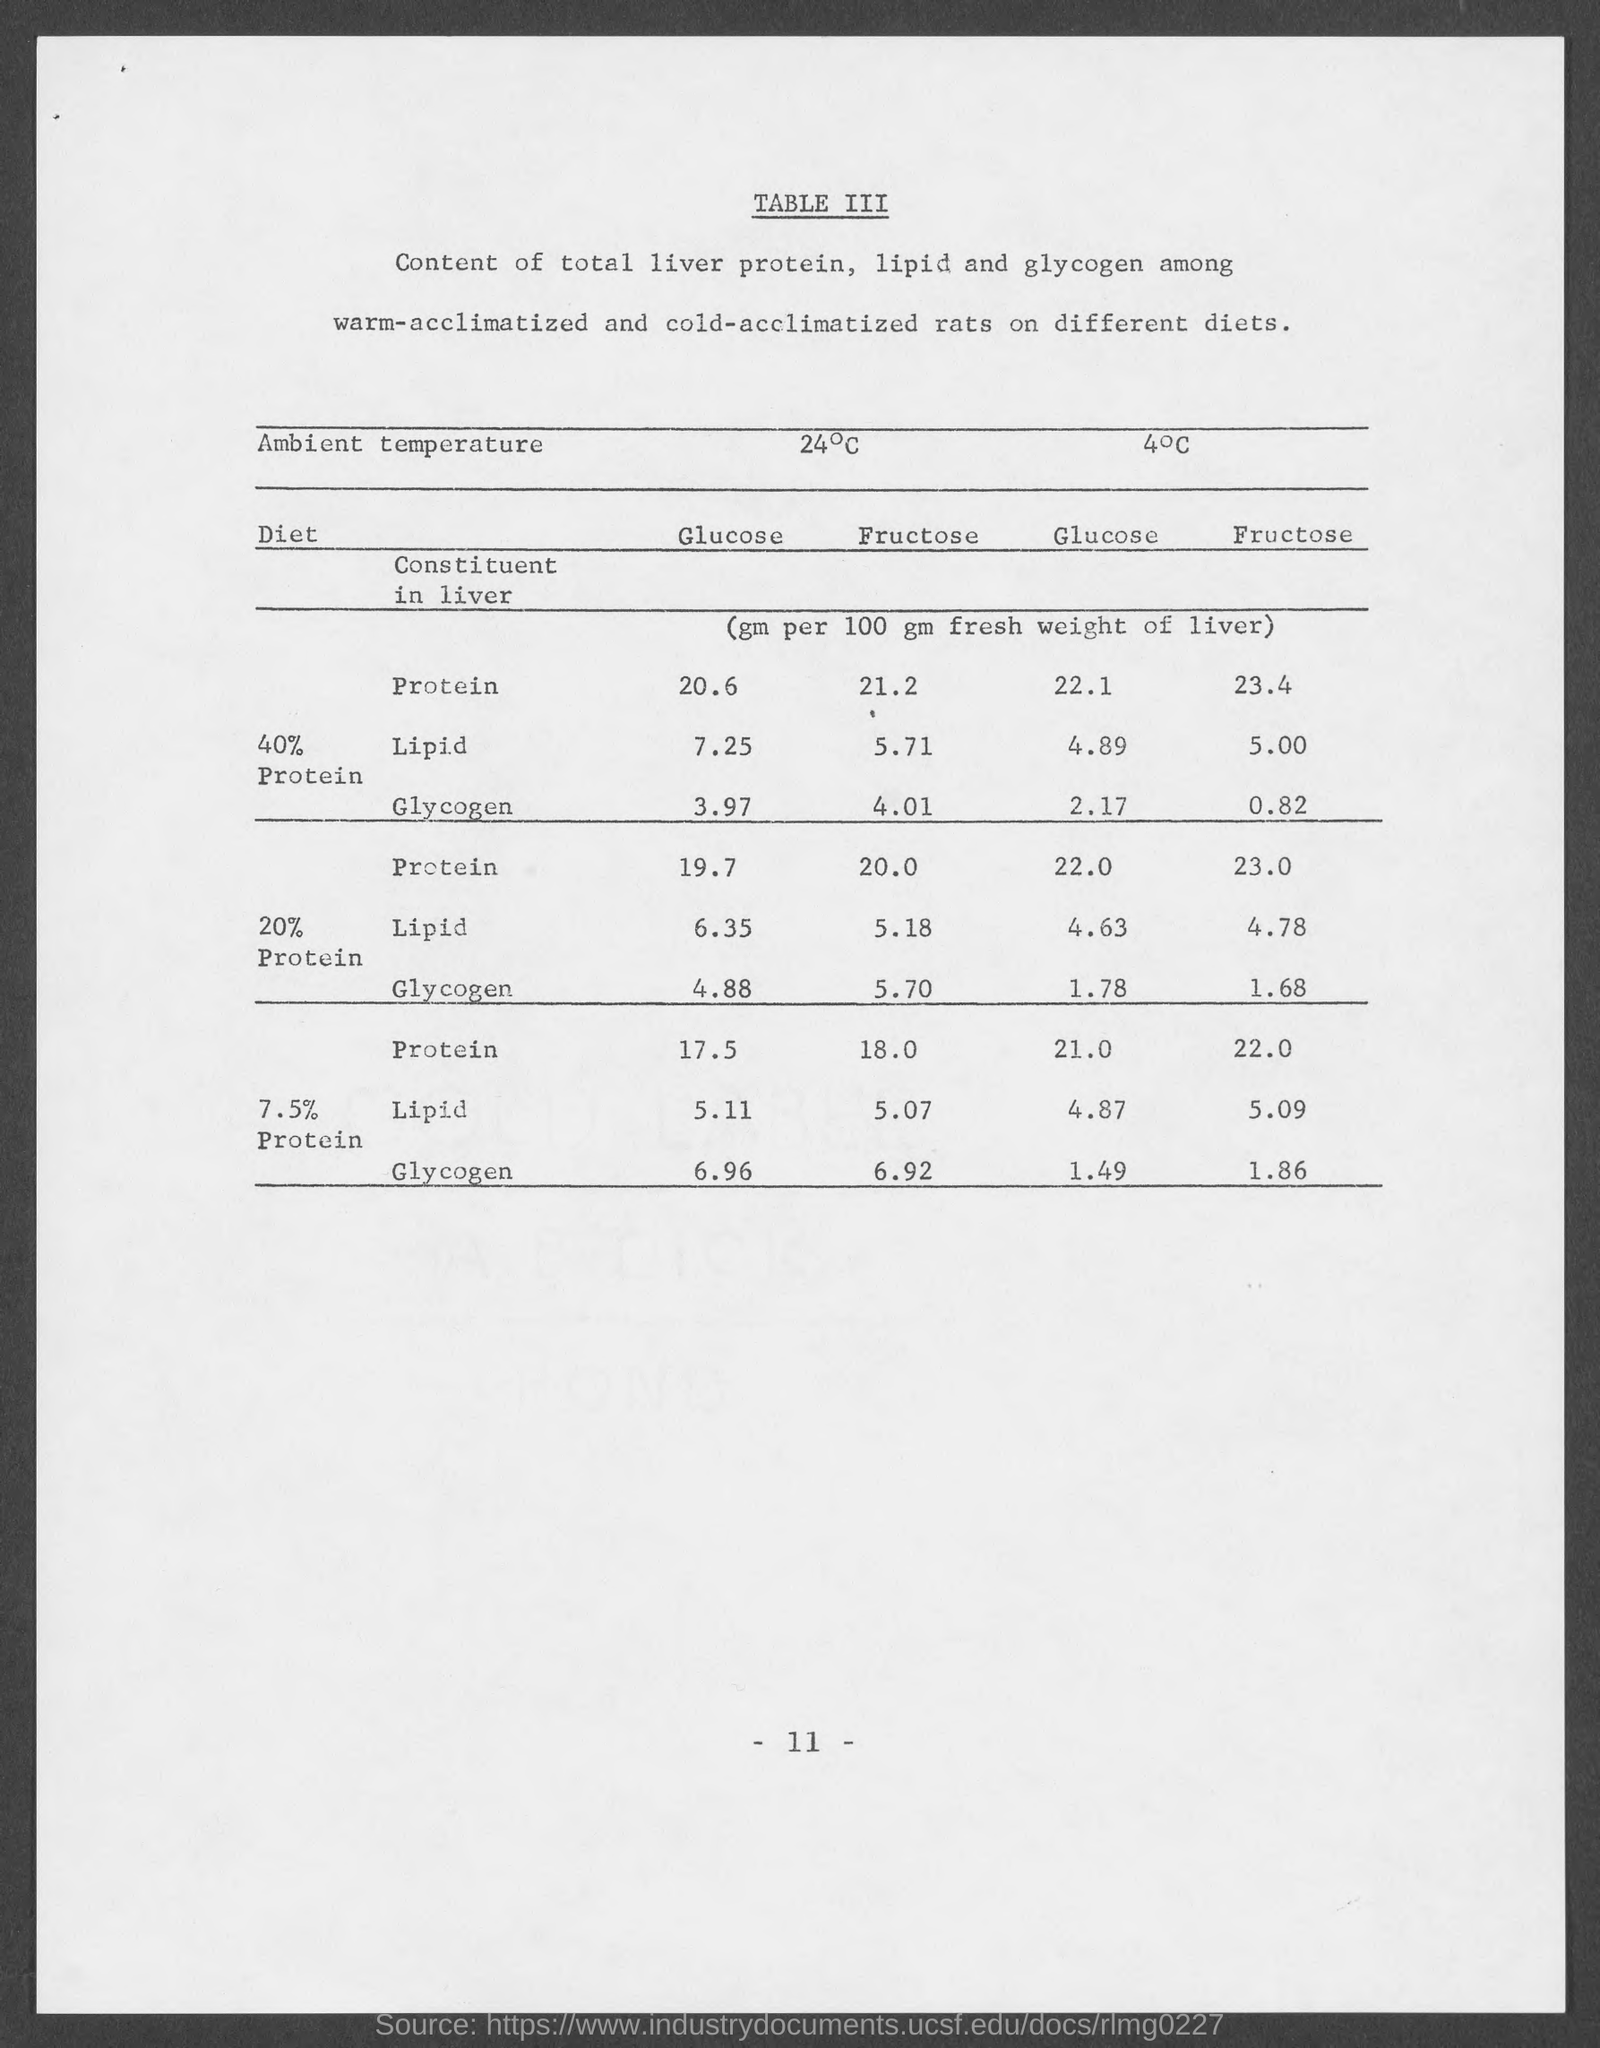What is the page number at bottom of the page?
Ensure brevity in your answer.  -11-. 